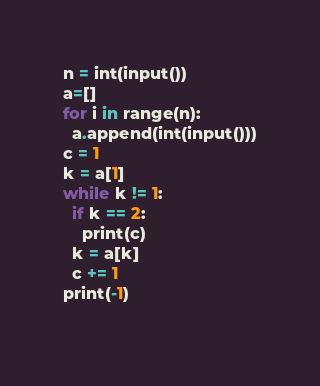Convert code to text. <code><loc_0><loc_0><loc_500><loc_500><_Python_>n = int(input())
a=[]
for i in range(n):
  a.append(int(input()))
c = 1
k = a[1]
while k != 1:
  if k == 2:
    print(c)
  k = a[k]
  c += 1
print(-1)  
  
</code> 